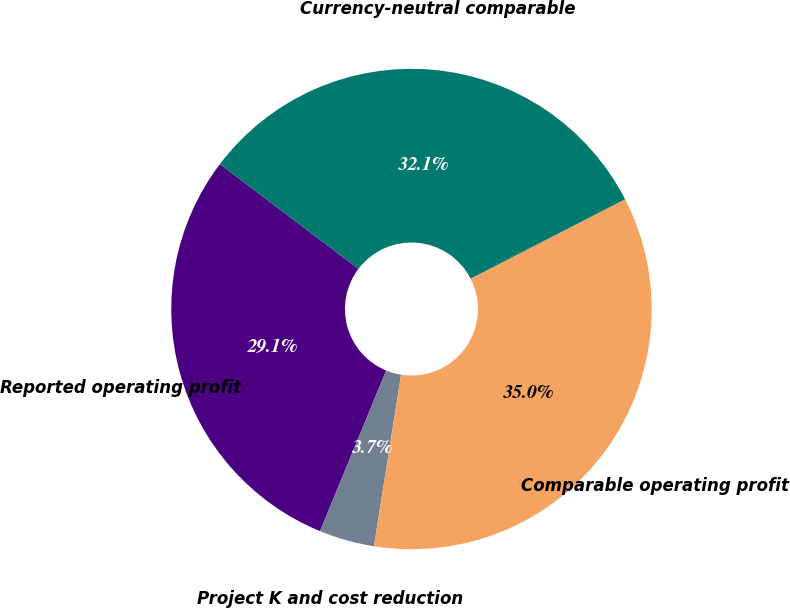Convert chart. <chart><loc_0><loc_0><loc_500><loc_500><pie_chart><fcel>Reported operating profit<fcel>Project K and cost reduction<fcel>Comparable operating profit<fcel>Currency-neutral comparable<nl><fcel>29.09%<fcel>3.72%<fcel>35.05%<fcel>32.14%<nl></chart> 